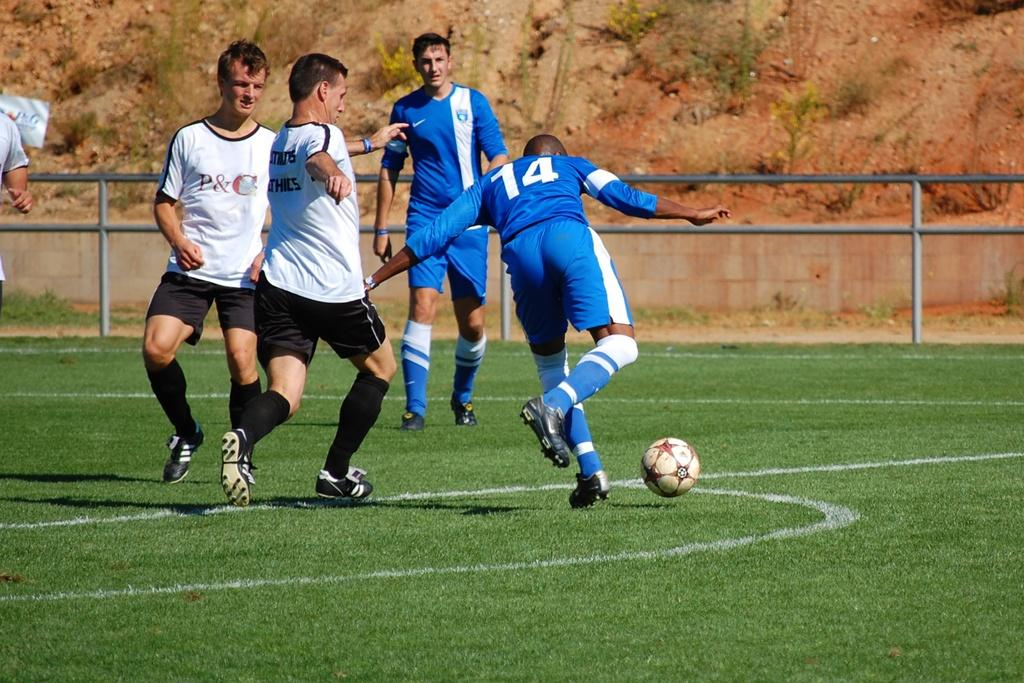<image>
Give a short and clear explanation of the subsequent image. Number 14 on the soccer field is getting ready to kick the ball. 